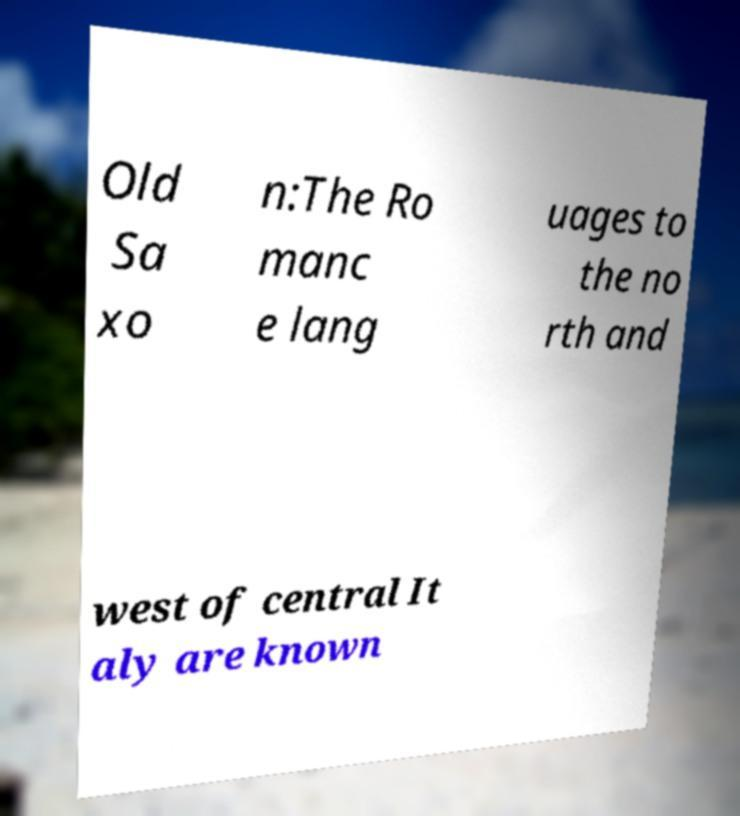Could you assist in decoding the text presented in this image and type it out clearly? Old Sa xo n:The Ro manc e lang uages to the no rth and west of central It aly are known 